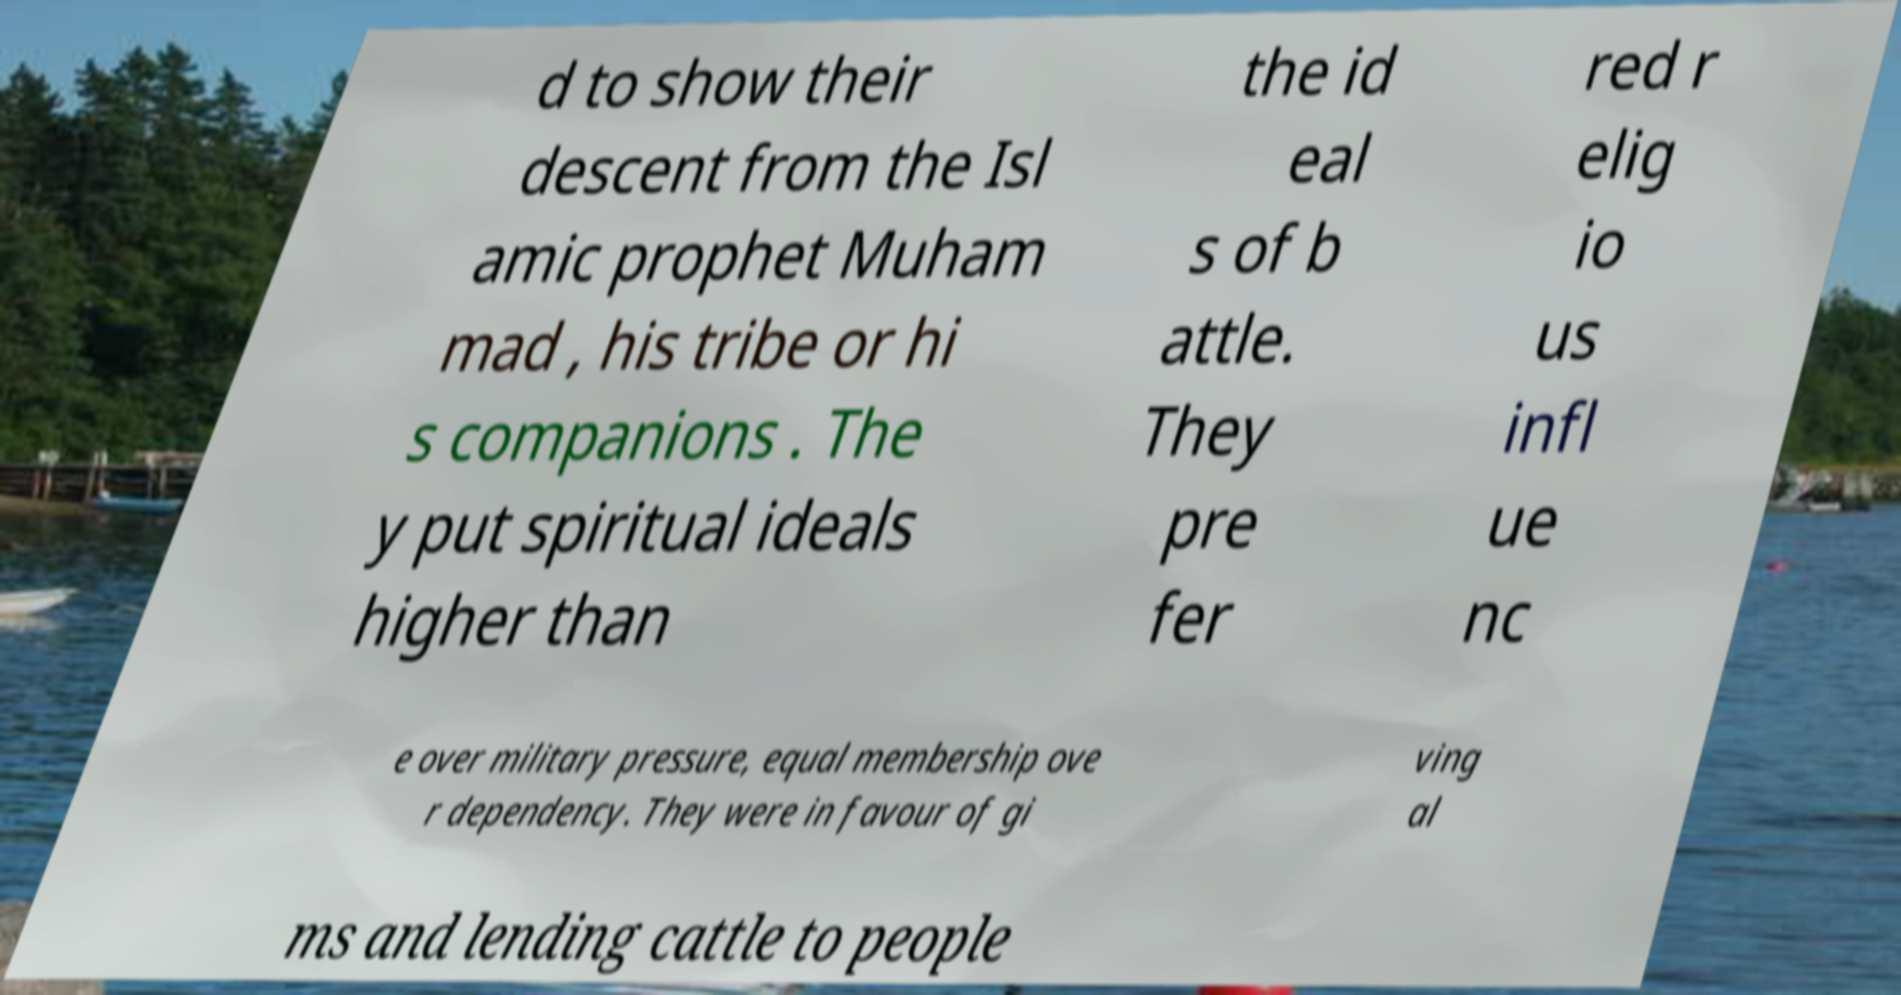I need the written content from this picture converted into text. Can you do that? d to show their descent from the Isl amic prophet Muham mad , his tribe or hi s companions . The y put spiritual ideals higher than the id eal s of b attle. They pre fer red r elig io us infl ue nc e over military pressure, equal membership ove r dependency. They were in favour of gi ving al ms and lending cattle to people 